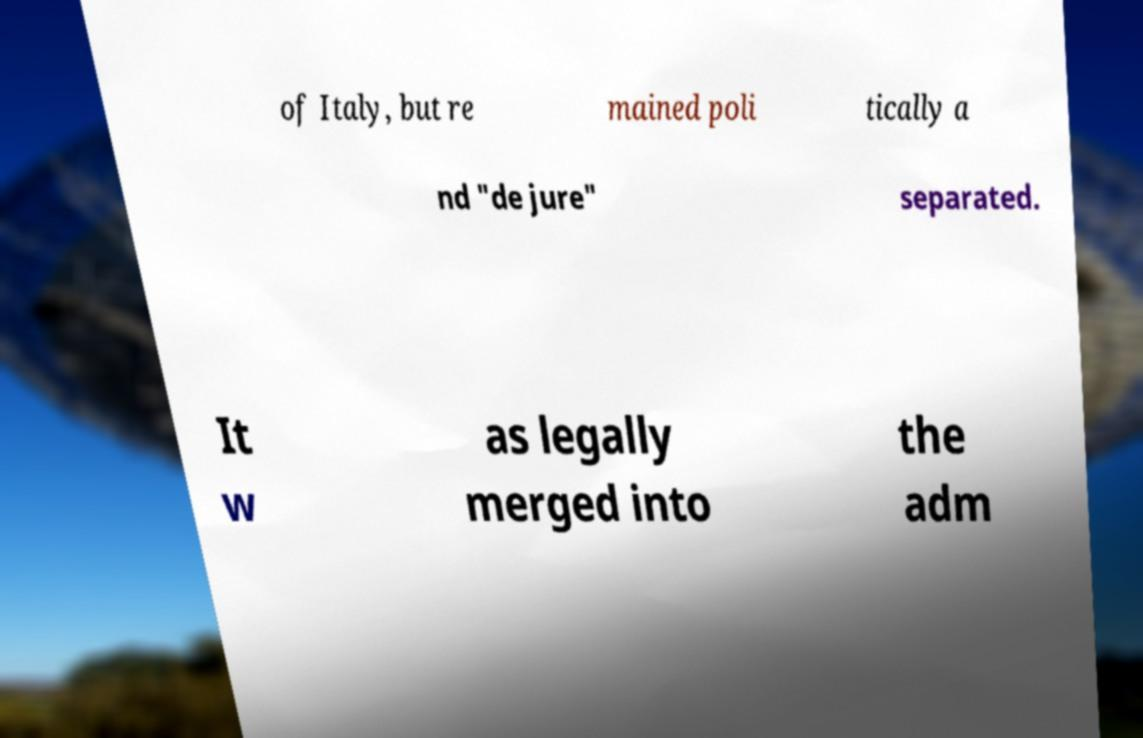Could you assist in decoding the text presented in this image and type it out clearly? of Italy, but re mained poli tically a nd "de jure" separated. It w as legally merged into the adm 